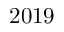<formula> <loc_0><loc_0><loc_500><loc_500>2 0 1 9</formula> 